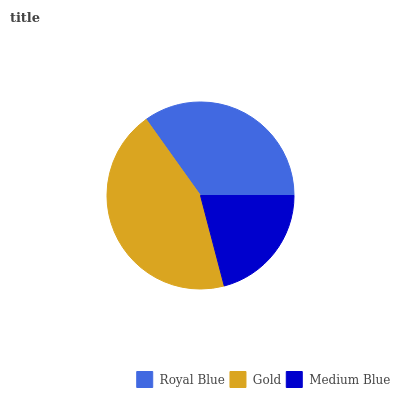Is Medium Blue the minimum?
Answer yes or no. Yes. Is Gold the maximum?
Answer yes or no. Yes. Is Gold the minimum?
Answer yes or no. No. Is Medium Blue the maximum?
Answer yes or no. No. Is Gold greater than Medium Blue?
Answer yes or no. Yes. Is Medium Blue less than Gold?
Answer yes or no. Yes. Is Medium Blue greater than Gold?
Answer yes or no. No. Is Gold less than Medium Blue?
Answer yes or no. No. Is Royal Blue the high median?
Answer yes or no. Yes. Is Royal Blue the low median?
Answer yes or no. Yes. Is Medium Blue the high median?
Answer yes or no. No. Is Gold the low median?
Answer yes or no. No. 